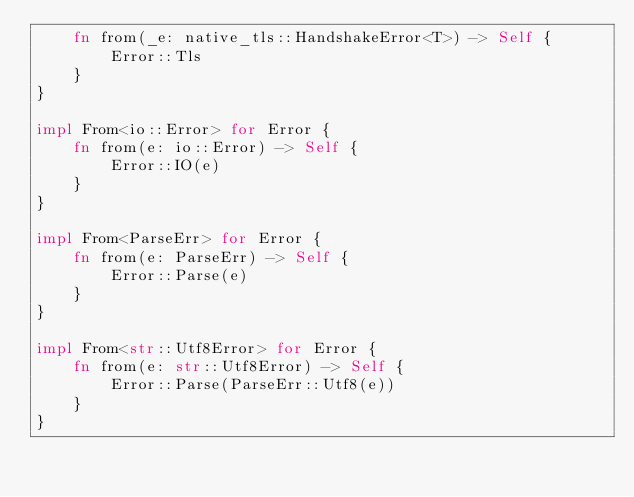<code> <loc_0><loc_0><loc_500><loc_500><_Rust_>    fn from(_e: native_tls::HandshakeError<T>) -> Self {
        Error::Tls
    }
}

impl From<io::Error> for Error {
    fn from(e: io::Error) -> Self {
        Error::IO(e)
    }
}

impl From<ParseErr> for Error {
    fn from(e: ParseErr) -> Self {
        Error::Parse(e)
    }
}

impl From<str::Utf8Error> for Error {
    fn from(e: str::Utf8Error) -> Self {
        Error::Parse(ParseErr::Utf8(e))
    }
}
</code> 